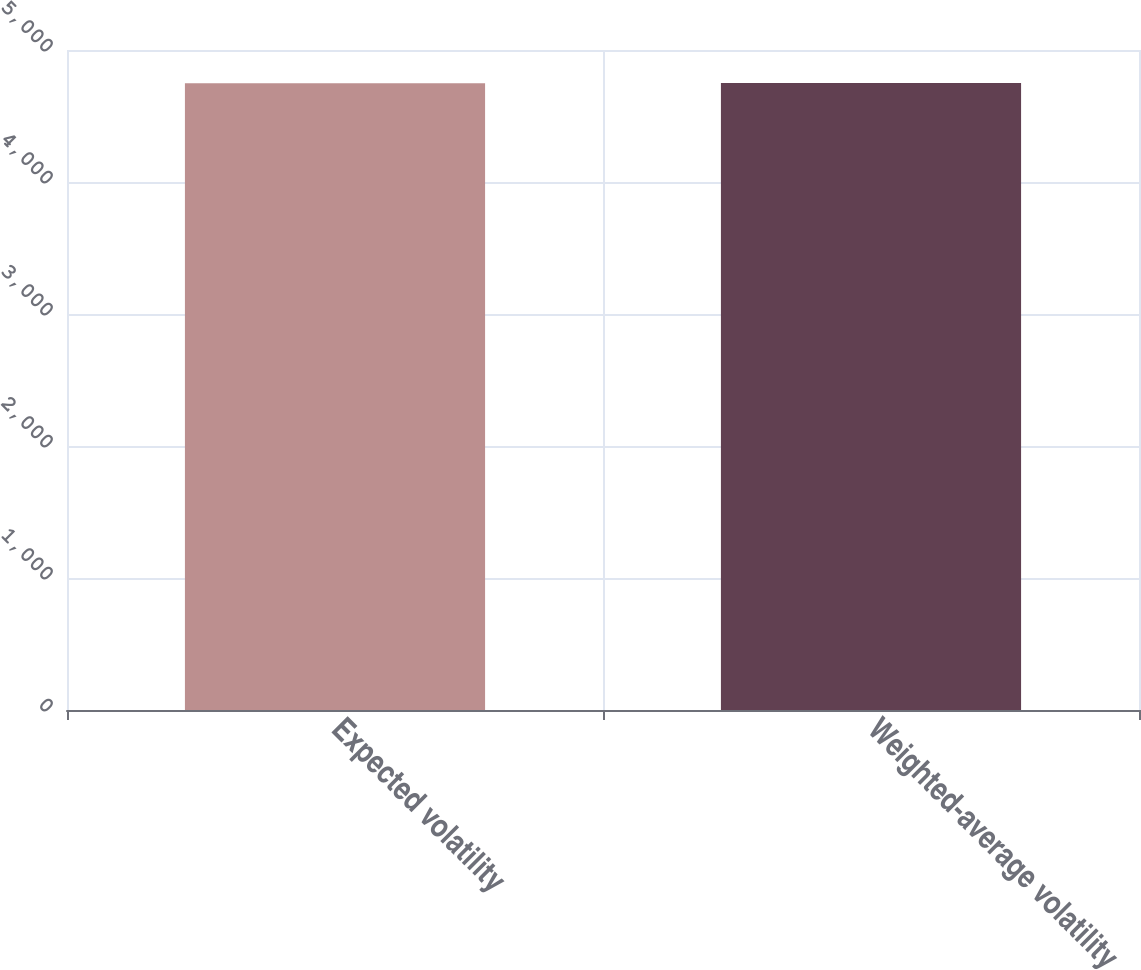Convert chart to OTSL. <chart><loc_0><loc_0><loc_500><loc_500><bar_chart><fcel>Expected volatility<fcel>Weighted-average volatility<nl><fcel>4749<fcel>4749.1<nl></chart> 